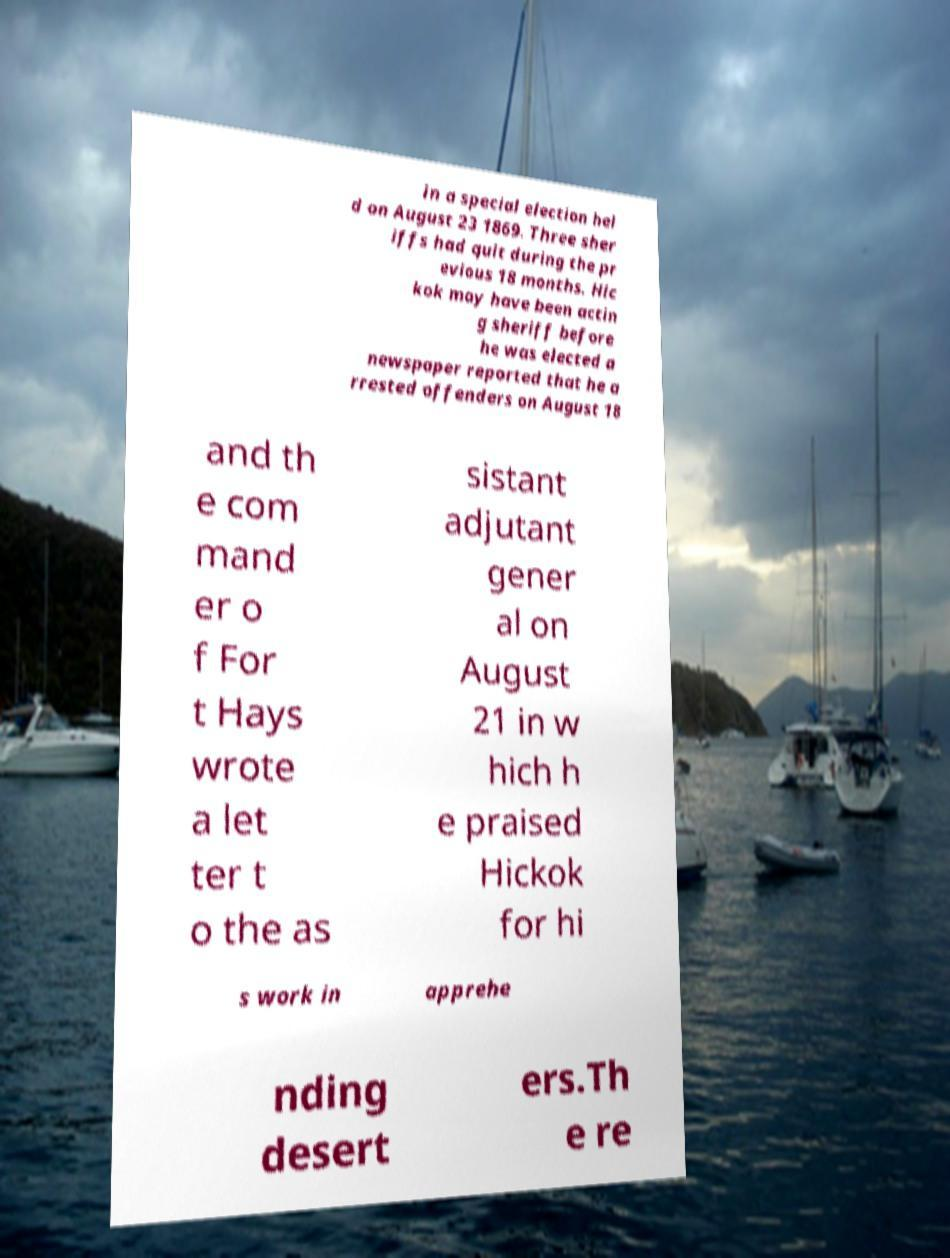Could you assist in decoding the text presented in this image and type it out clearly? in a special election hel d on August 23 1869. Three sher iffs had quit during the pr evious 18 months. Hic kok may have been actin g sheriff before he was elected a newspaper reported that he a rrested offenders on August 18 and th e com mand er o f For t Hays wrote a let ter t o the as sistant adjutant gener al on August 21 in w hich h e praised Hickok for hi s work in apprehe nding desert ers.Th e re 